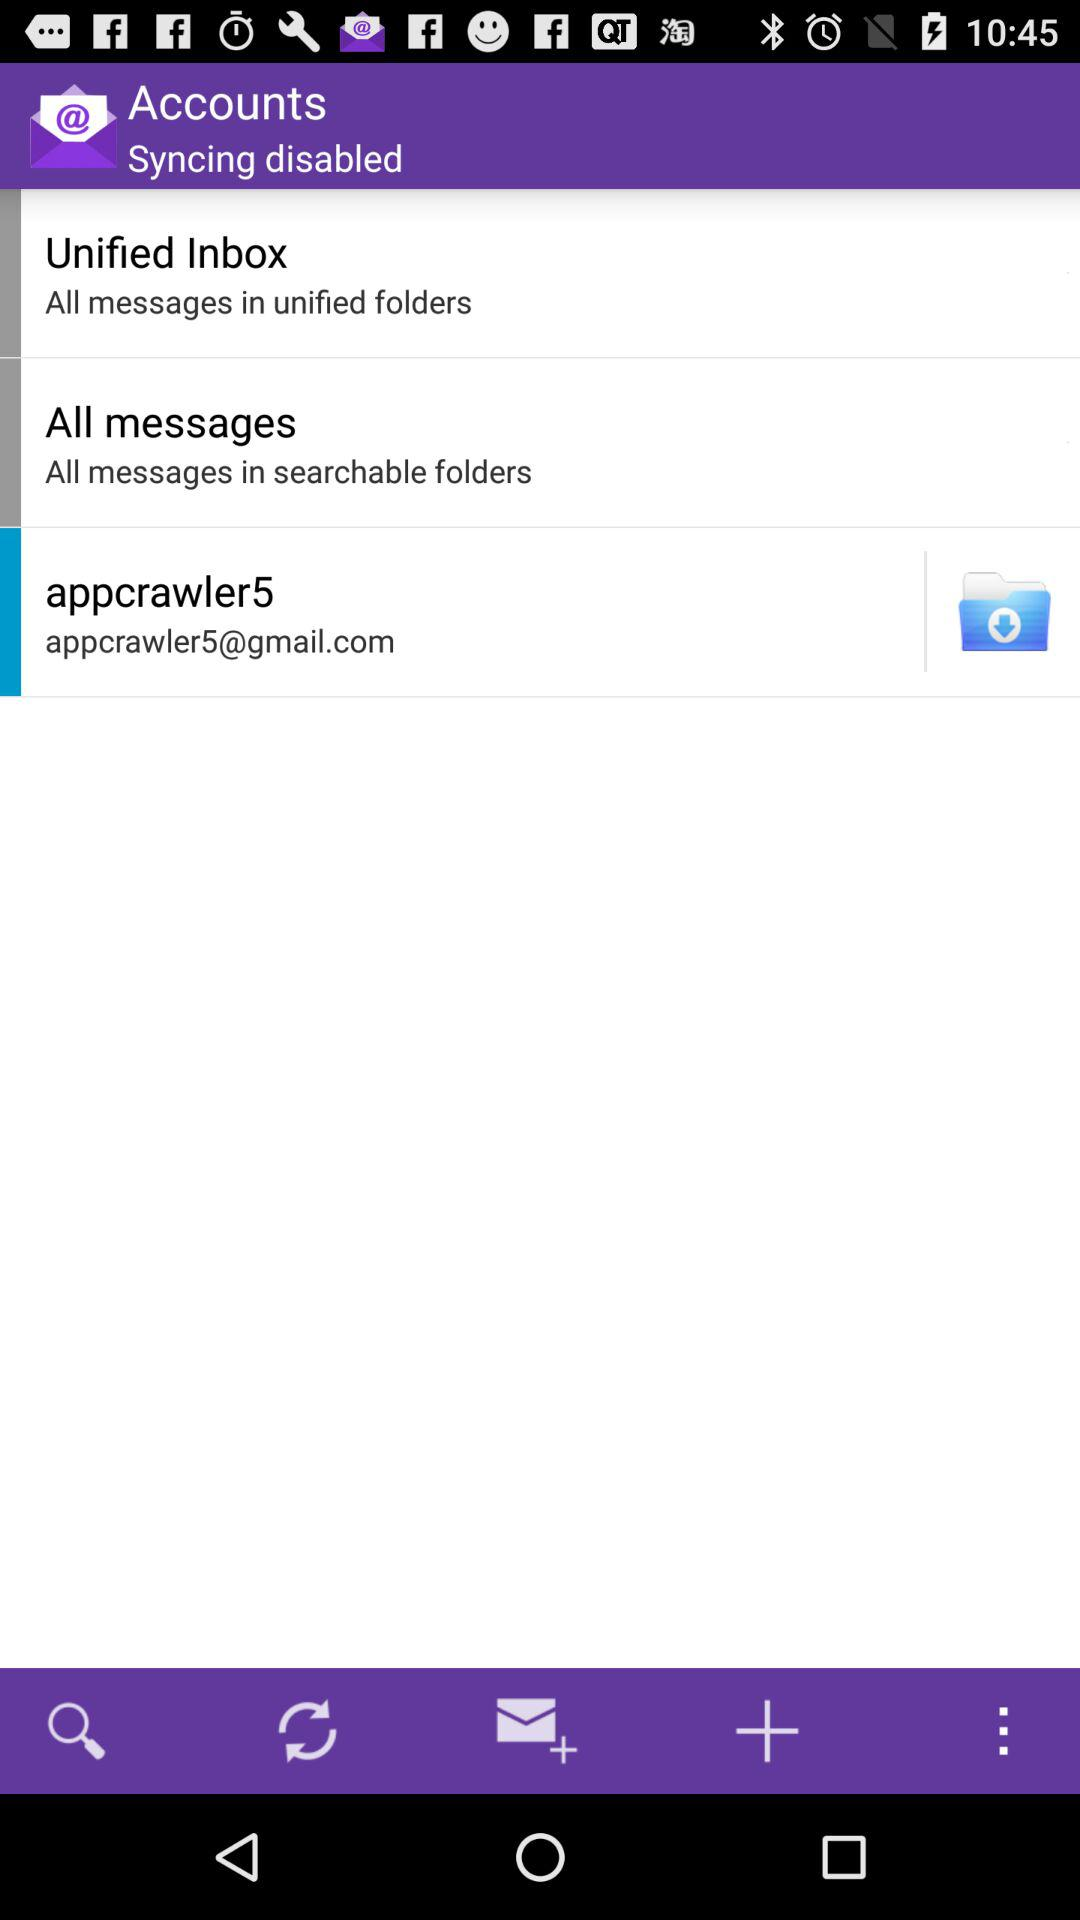What is the email address? The email address is appcrawler5@gmail.com. 